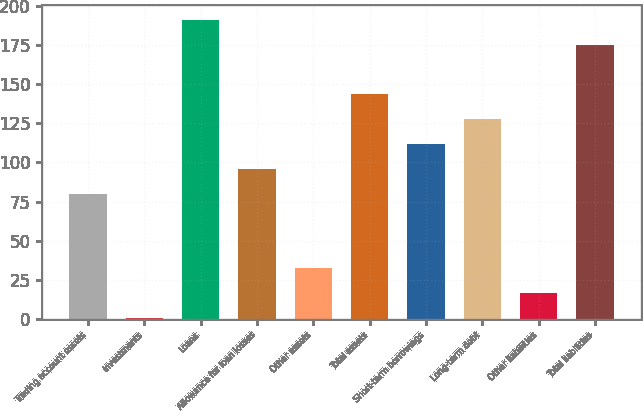Convert chart to OTSL. <chart><loc_0><loc_0><loc_500><loc_500><bar_chart><fcel>Trading account assets<fcel>Investments<fcel>Loans<fcel>Allowance for loan losses<fcel>Other assets<fcel>Total assets<fcel>Short-term borrowings<fcel>Long-term debt<fcel>Other liabilities<fcel>Total liabilities<nl><fcel>80<fcel>0.6<fcel>191.16<fcel>95.88<fcel>32.36<fcel>143.52<fcel>111.76<fcel>127.64<fcel>16.48<fcel>175.28<nl></chart> 